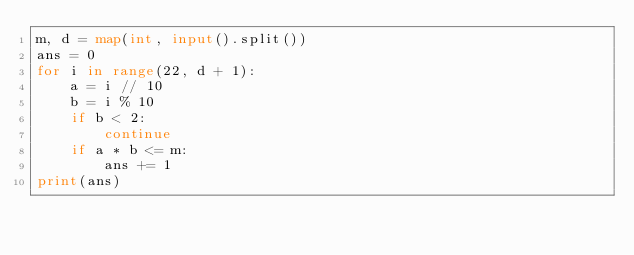<code> <loc_0><loc_0><loc_500><loc_500><_Python_>m, d = map(int, input().split())
ans = 0
for i in range(22, d + 1):
    a = i // 10
    b = i % 10
    if b < 2:
        continue
    if a * b <= m:
        ans += 1
print(ans)
</code> 